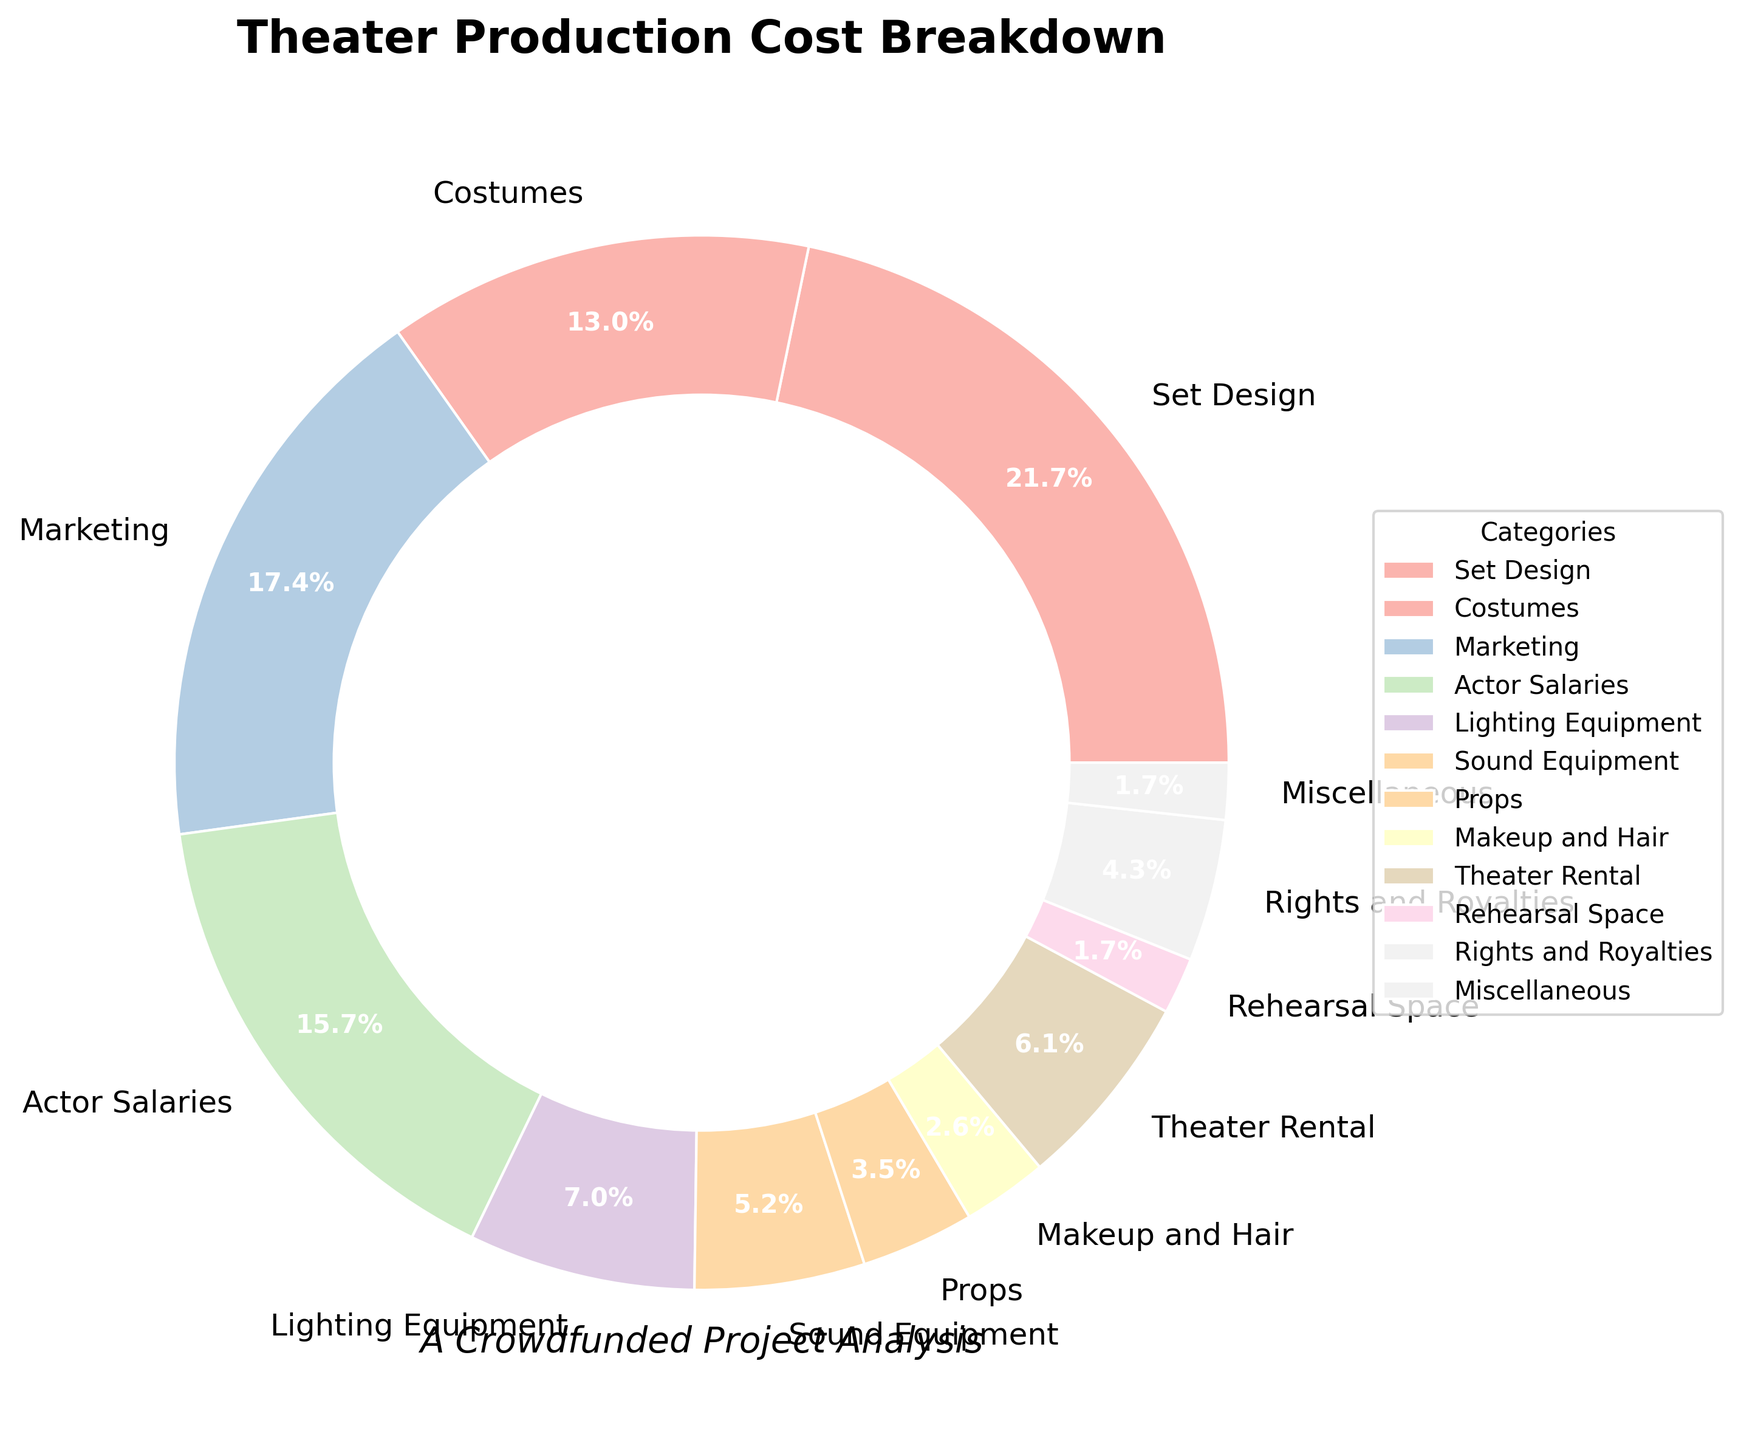Which category takes up the largest portion of the theater production costs? The largest segment in the pie chart represents the category with the highest percentage. By visually identifying the largest wedge, we can see that Set Design takes up the largest portion.
Answer: Set Design What is the total percentage of costs associated with actor salaries and costumes combined? To find the combined percentage, we add the percentages of Actor Salaries and Costumes. Actor Salaries is 18% and Costumes is 15%, so 18% + 15% = 33%.
Answer: 33% How much more is allocated to marketing compared to the miscellaneous category? Subtract the percentage of Miscellaneous costs from Marketing costs. Marketing is 20% and Miscellaneous is 2%, so 20% - 2% = 18%.
Answer: 18% Compare the costs between lighting equipment and sound equipment. Which one has a higher allocation? By looking at the pie chart, we can see that Lighting Equipment has an 8% allocation while Sound Equipment has 6%. So, Lighting Equipment has a higher allocation.
Answer: Lighting Equipment Which two categories have the smallest allocation of costs, and what is their combined percentage? By identifying the smallest segments in the pie chart, Rehearsal Space (2%) and Miscellaneous (2%) are the categories with the smallest allocations. The combined percentage is 2% + 2% = 4%.
Answer: Rehearsal Space and Miscellaneous, 4% What is the difference in cost allocation between set design and theater rental? Subtract the percentage of Theater Rental costs from Set Design costs. Set Design is 25% and Theater Rental is 7%, so 25% - 7% = 18%.
Answer: 18% If the total budget is $200,000, how much money is allocated to costumes? Calculate the dollar amount by multiplying the total budget by the percentage for Costumes. Costumes is 15%, so $200,000 * 0.15 = $30,000.
Answer: $30,000 Which category contributes less to the total costs: makeup and hair or rights and royalties? By comparing the wedges in the pie chart, Makeup and Hair has a 3% allocation while Rights and Royalties has 5%. Therefore, Makeup and Hair contributes less.
Answer: Makeup and Hair What percentage of the budget goes towards technical departments (Lighting Equipment + Sound Equipment)? Add the percentages of Lighting Equipment and Sound Equipment. Lighting Equipment is 8% and Sound Equipment is 6%, so 8% + 6% = 14%.
Answer: 14% How does the allocation for marketing compare to that for actor salaries? By comparing the sizes of the wedges in the pie chart, Marketing has a 20% allocation while Actor Salaries has 18%. Therefore, Marketing has a higher allocation.
Answer: Marketing 